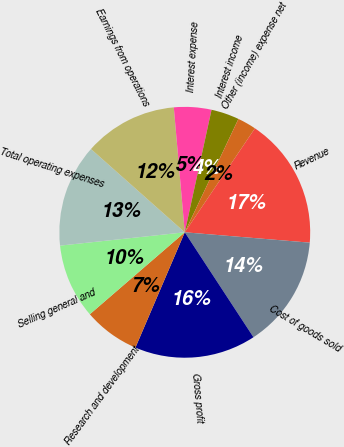Convert chart to OTSL. <chart><loc_0><loc_0><loc_500><loc_500><pie_chart><fcel>Revenue<fcel>Cost of goods sold<fcel>Gross profit<fcel>Research and development<fcel>Selling general and<fcel>Total operating expenses<fcel>Earnings from operations<fcel>Interest expense<fcel>Interest income<fcel>Other (income) expense net<nl><fcel>16.87%<fcel>14.46%<fcel>15.66%<fcel>7.23%<fcel>9.64%<fcel>13.25%<fcel>12.05%<fcel>4.82%<fcel>3.61%<fcel>2.41%<nl></chart> 